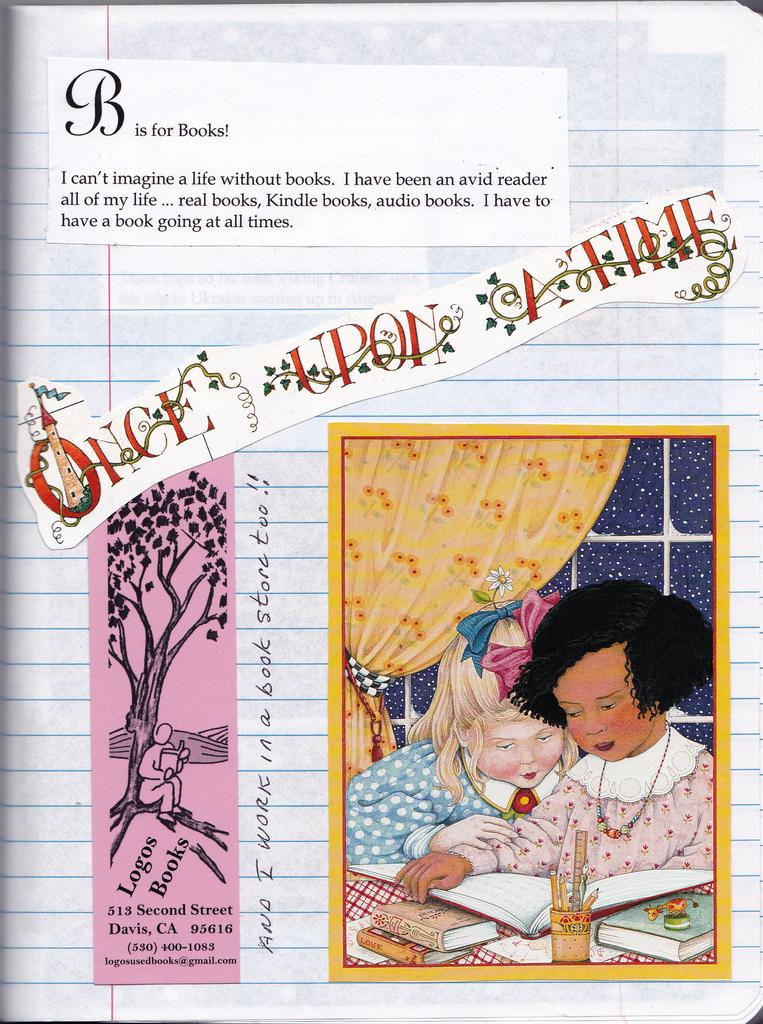What is the main subject of the image? The main subject of the image is a page of a book. What is on the page of the book? There are stickers on the page. What do the stickers contain? The stickers contain text and images. What type of mother is depicted in the scene on the sticker? There is no scene or mother present in the image; it only contains a page of a book with stickers. 